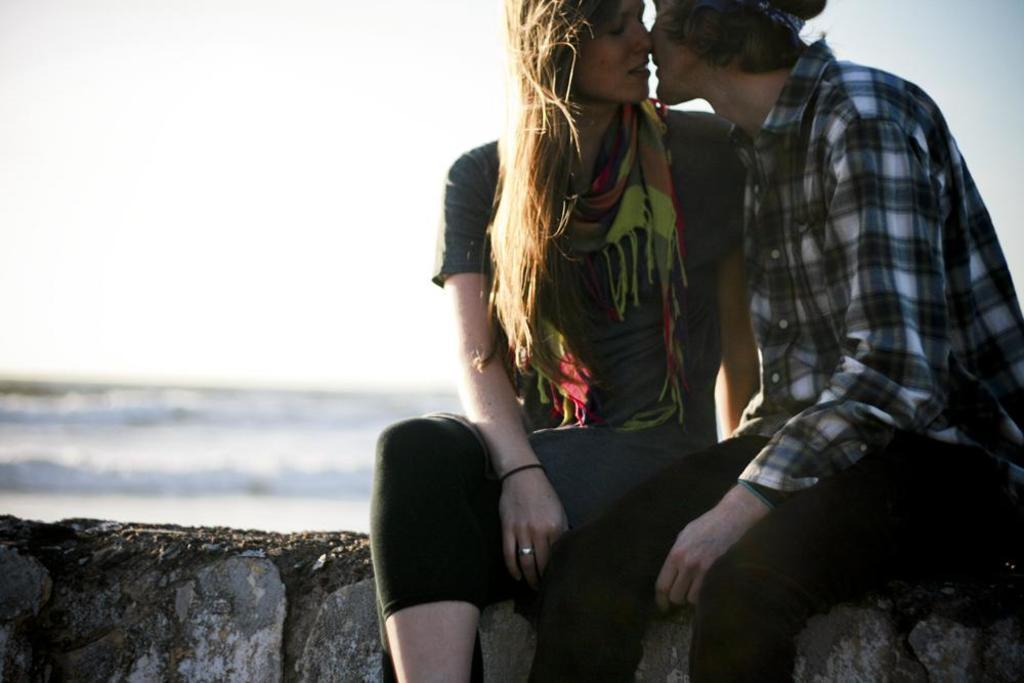What are the people in the image doing? The people in the image are sitting. What can be seen behind the people? There is a wall visible in the image. What is visible in the distance behind the wall? There is water and the sky visible in the background of the image. What type of produce is being harvested in the image? There is no produce or harvesting activity visible in the image. What is the position of the front row of people in the image? There is no reference to a front row of people in the image, as it only mentions that people are sitting. 